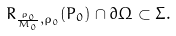Convert formula to latex. <formula><loc_0><loc_0><loc_500><loc_500>R _ { \frac { \rho _ { 0 } } { M _ { 0 } } , \rho _ { 0 } } ( P _ { 0 } ) \cap \partial \Omega \subset \Sigma .</formula> 